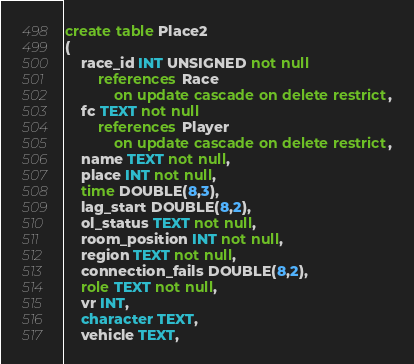Convert code to text. <code><loc_0><loc_0><loc_500><loc_500><_SQL_>create table Place2
(
	race_id INT UNSIGNED not null
		references Race
			on update cascade on delete restrict,
	fc TEXT not null
		references Player
			on update cascade on delete restrict,
	name TEXT not null,
	place INT not null,
	time DOUBLE(8,3),
	lag_start DOUBLE(8,2),
	ol_status TEXT not null,
	room_position INT not null,
	region TEXT not null,
	connection_fails DOUBLE(8,2),
	role TEXT not null,
	vr INT,
	character TEXT,
	vehicle TEXT,</code> 